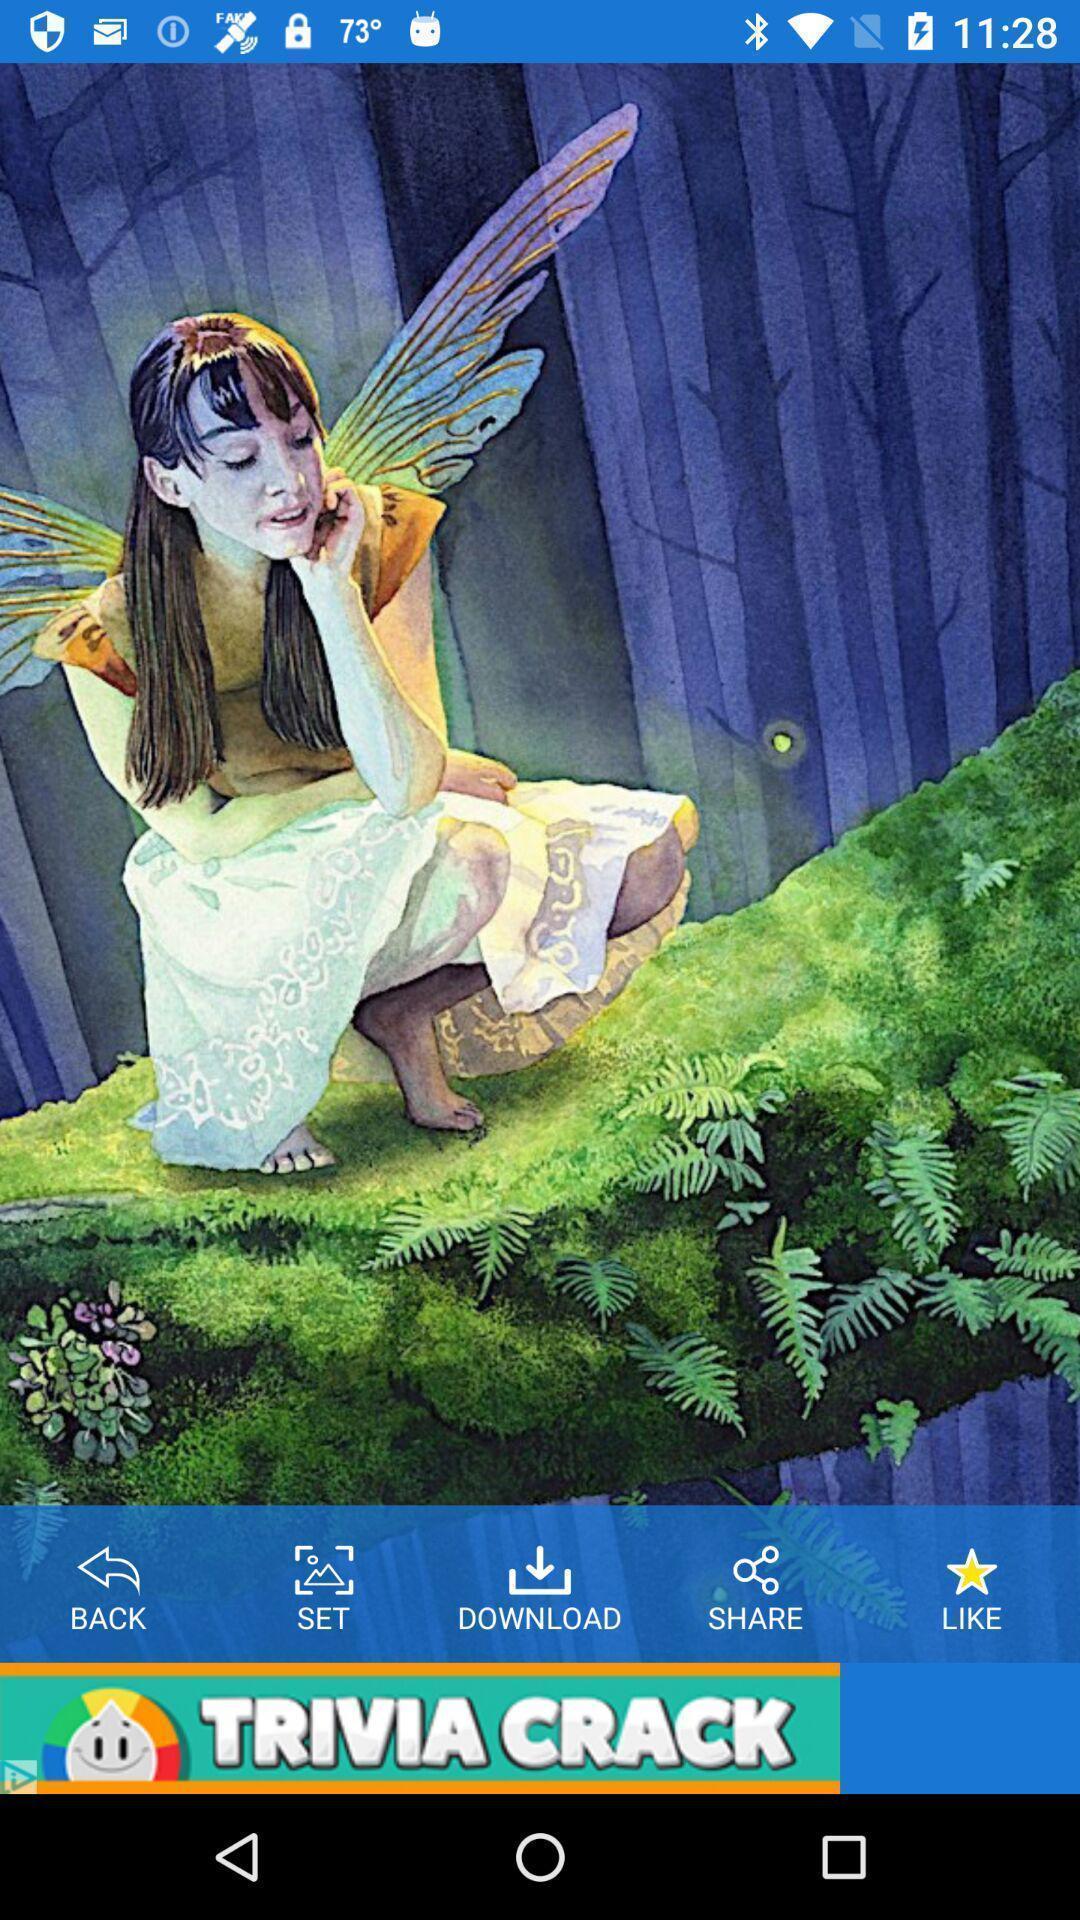Explain what's happening in this screen capture. Welcome page displaying with different options. 